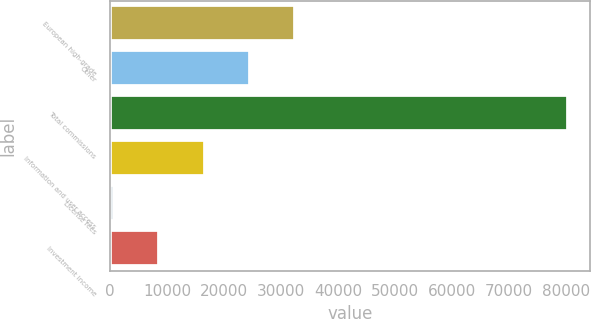Convert chart. <chart><loc_0><loc_0><loc_500><loc_500><bar_chart><fcel>European high-grade<fcel>Other<fcel>Total commissions<fcel>Information and user access<fcel>License fees<fcel>Investment income<nl><fcel>32498.4<fcel>24545.8<fcel>80214<fcel>16593.2<fcel>688<fcel>8640.6<nl></chart> 